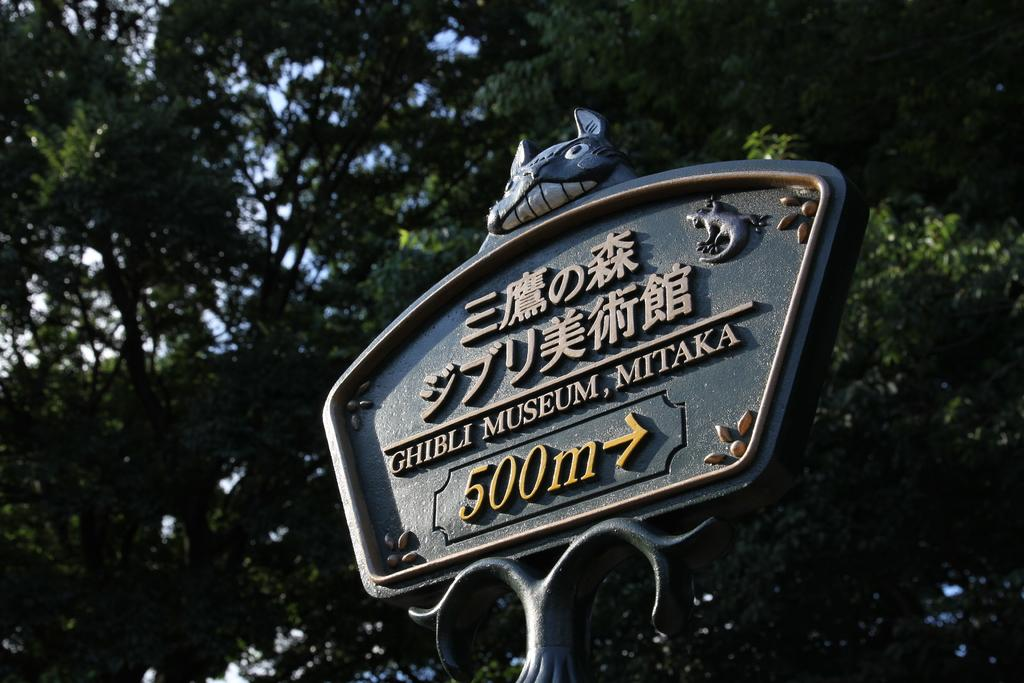What type of structure is present in the image? There is a metal structure in the image. Is there any text on the metal structure? Yes, the metal structure has some text on it. Where is the text located on the metal structure? The text is located at the top of the pole. What can be seen on the metal structure besides the text? There is a depiction of an animal on the metal structure. What can be seen in the background of the image? There are trees in the background of the image. What type of machine is being used by the spy in the image? There is no machine or spy present in the image; it features a metal structure with text and an animal depiction. What musical instrument is being played by the animal on the metal structure? There is no musical instrument being played by the animal on the metal structure; it is a depiction of an animal, not a live animal. 